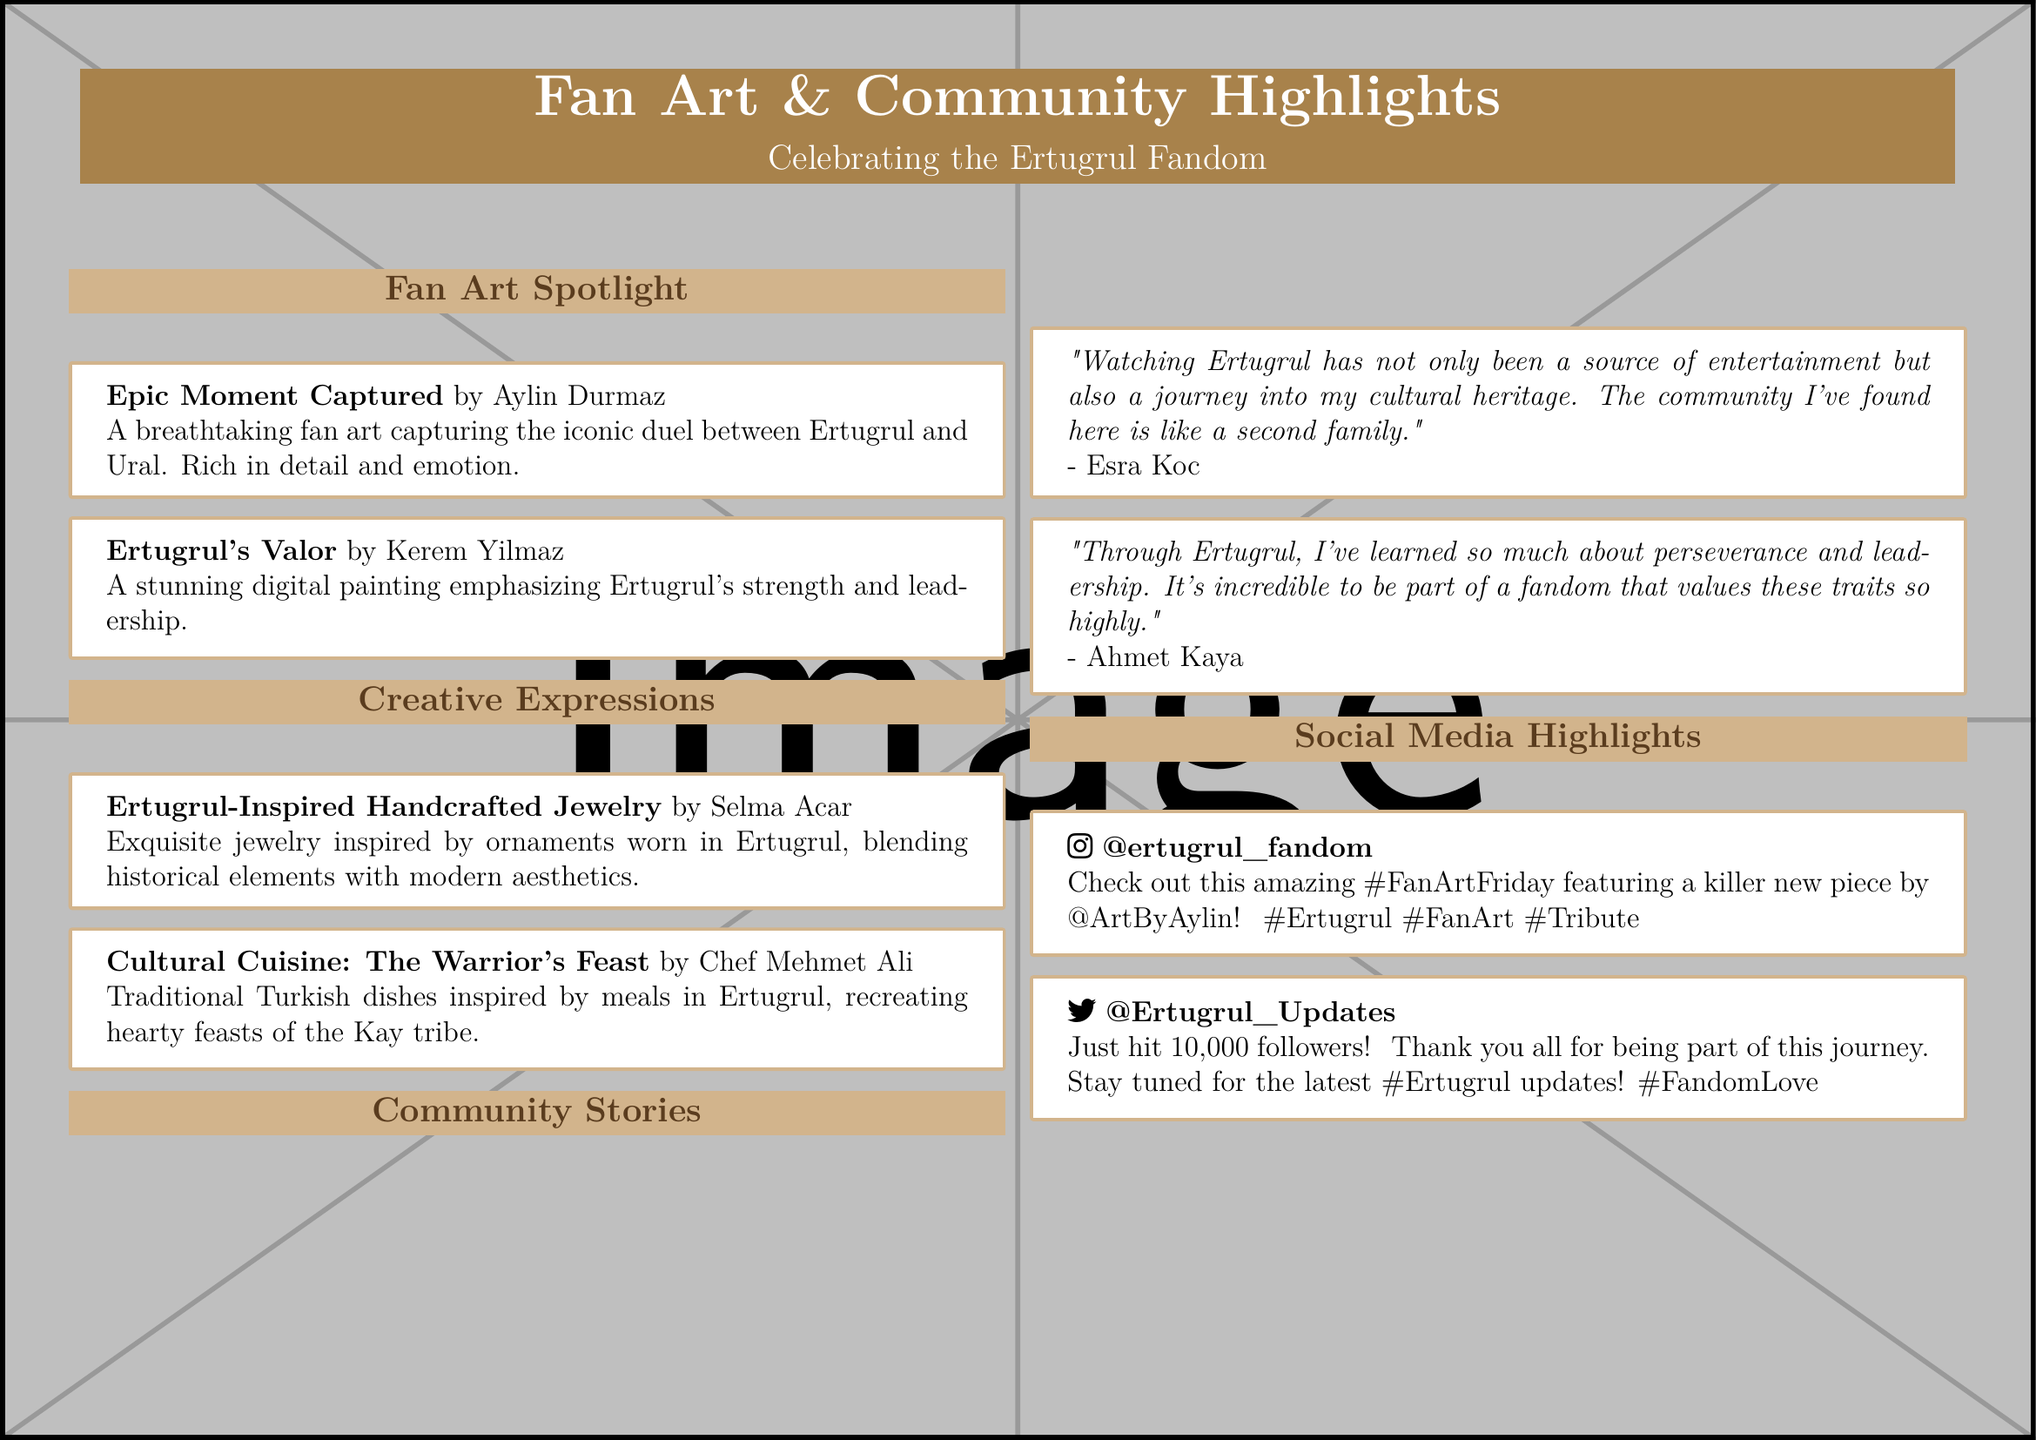What is the title of the feature? The title of the feature is a prominent header indicating the coverage of fan art and community storytelling in relation to the Ertugrul fandom.
Answer: Fan Art & Community Highlights Who created the artwork titled "Epic Moment Captured"? This question pertains to the artist who produced a specific piece of fan art featured in the document.
Answer: Aylin Durmaz What is the theme of the handcrafted jewelry featured? The jewelry showcased is inspired by the historical elements associated with Ertugrul's narrative.
Answer: Ertugrul-inspired How many followers does @Ertugrul_Updates have? This asks for a specific numerical detail mentioned in the social media highlight section of the document.
Answer: 10,000 followers Who expressed feelings of cultural heritage in the community stories? This question focuses on a personal quote shared in the document, reflecting communal sentimental value.
Answer: Esra Koc What type of cuisine is highlighted in the creative expressions? The question seeks to identify the culinary theme presented in the document's creative section.
Answer: Traditional Turkish dishes What emotional attribute is emphasized in the painting "Ertugrul's Valor"? This asks about the central concept portrayed by the digital artist in their representation of Ertugrul.
Answer: Strength and leadership What social media platform is mentioned for @ertugrul_fandom? The question focuses on identifying the specific social media channel used for fan engagement in the document.
Answer: Instagram 